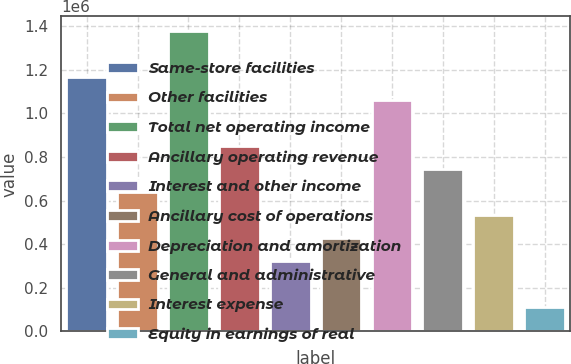Convert chart to OTSL. <chart><loc_0><loc_0><loc_500><loc_500><bar_chart><fcel>Same-store facilities<fcel>Other facilities<fcel>Total net operating income<fcel>Ancillary operating revenue<fcel>Interest and other income<fcel>Ancillary cost of operations<fcel>Depreciation and amortization<fcel>General and administrative<fcel>Interest expense<fcel>Equity in earnings of real<nl><fcel>1.16528e+06<fcel>638523<fcel>1.37598e+06<fcel>849225<fcel>322471<fcel>427822<fcel>1.05993e+06<fcel>743874<fcel>533172<fcel>111769<nl></chart> 